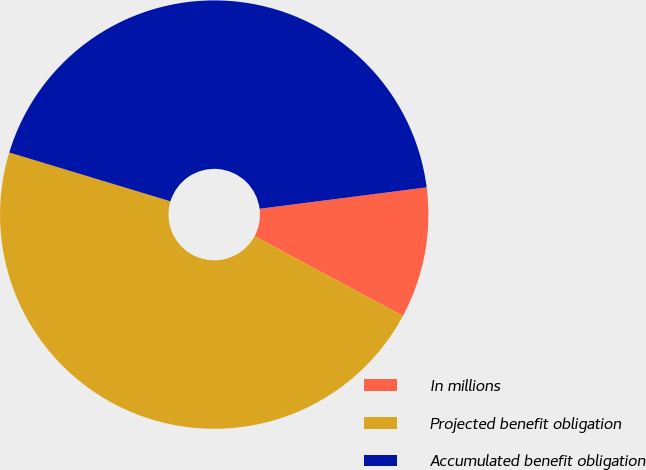Convert chart to OTSL. <chart><loc_0><loc_0><loc_500><loc_500><pie_chart><fcel>In millions<fcel>Projected benefit obligation<fcel>Accumulated benefit obligation<nl><fcel>9.87%<fcel>46.84%<fcel>43.29%<nl></chart> 